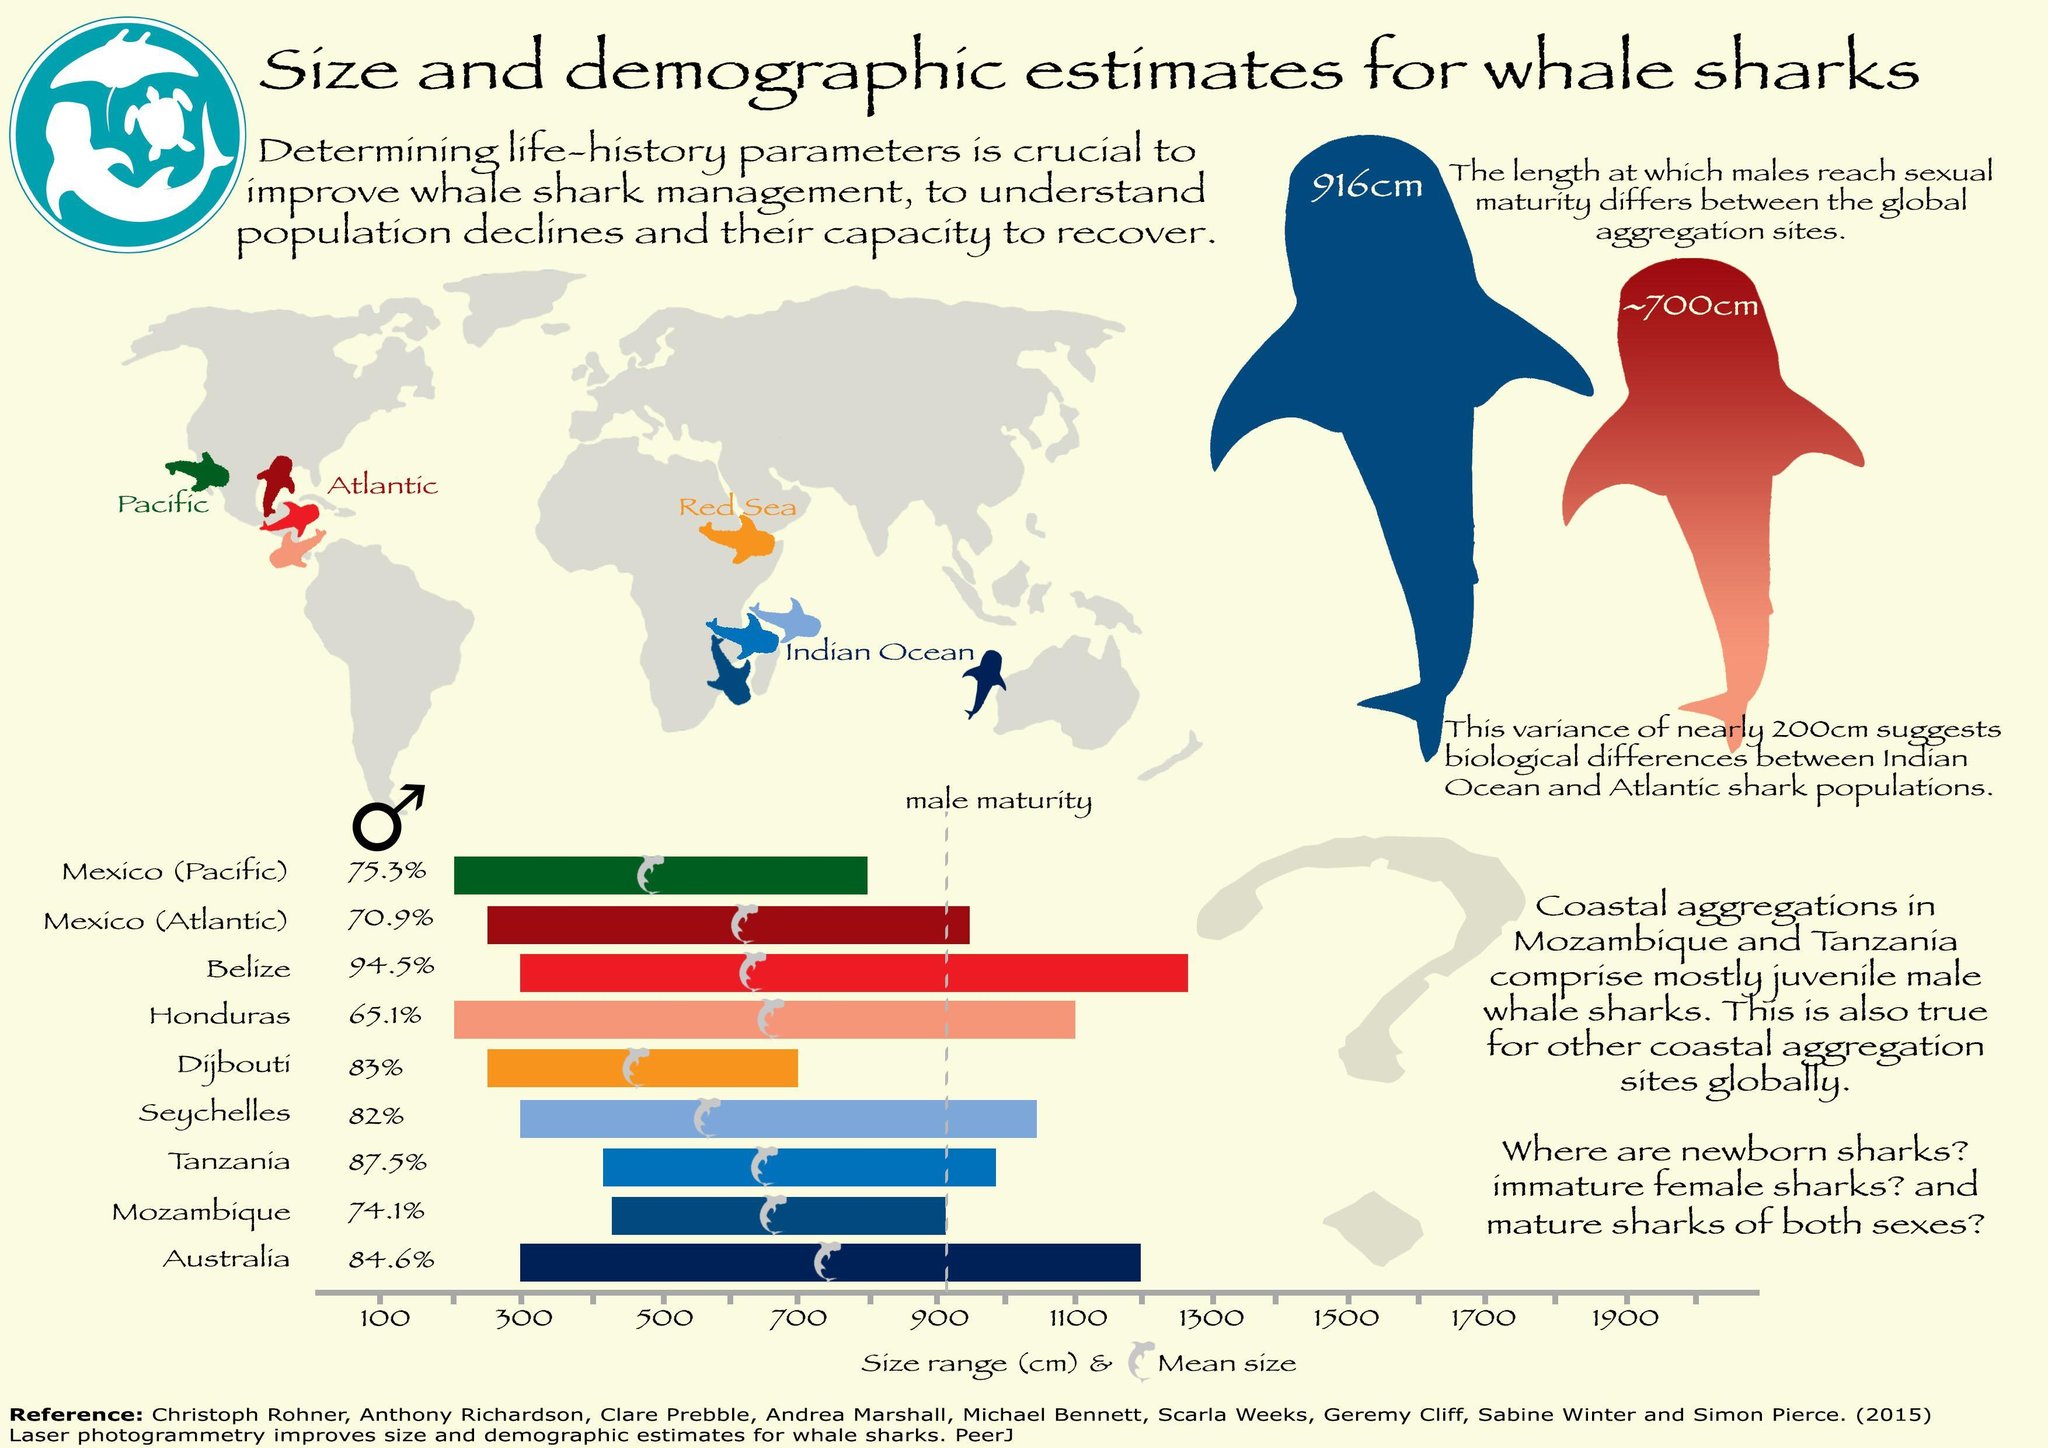At approximately what length do Atlantic whale sharks reach sexual maturity?
Answer the question with a short phrase. 700cm Whale sharks from which demographic area reach sexual maturity at a length of 916 cm? Indian Ocean 